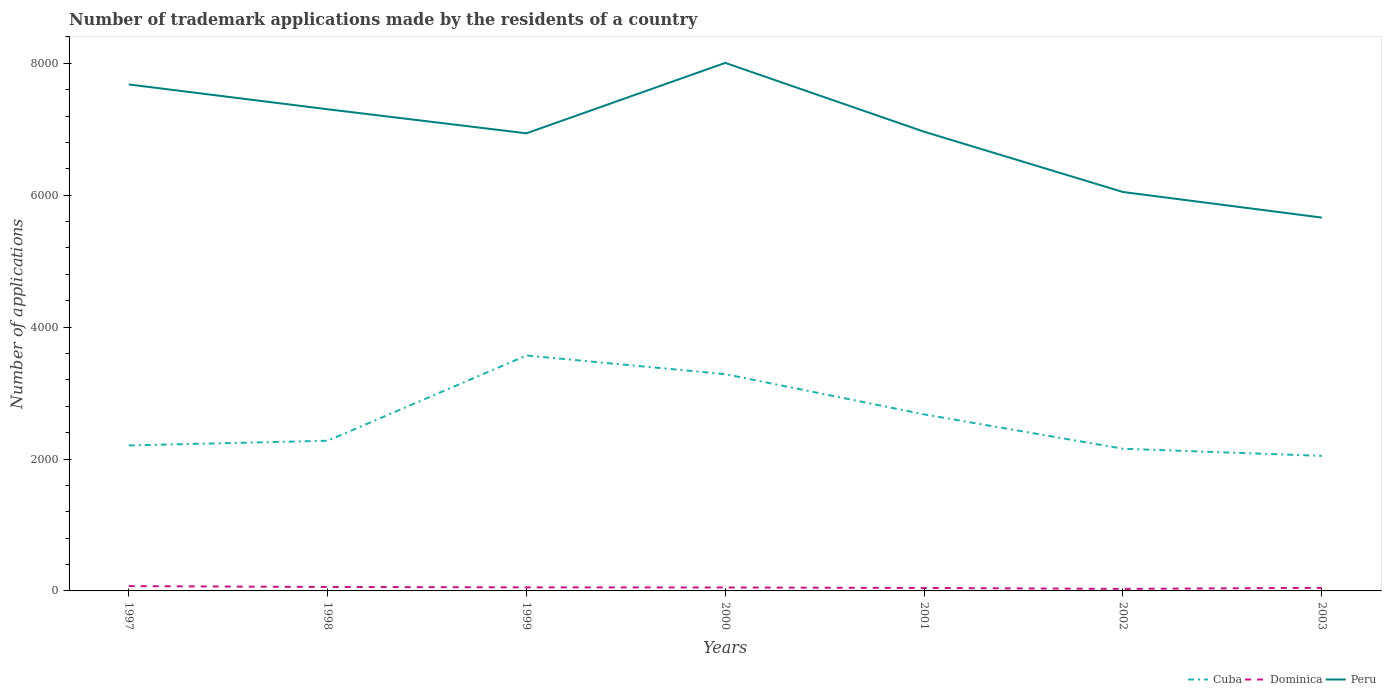How many different coloured lines are there?
Provide a short and direct response. 3. Does the line corresponding to Dominica intersect with the line corresponding to Cuba?
Your answer should be compact. No. Across all years, what is the maximum number of trademark applications made by the residents in Peru?
Offer a terse response. 5661. In which year was the number of trademark applications made by the residents in Dominica maximum?
Your answer should be very brief. 2002. What is the total number of trademark applications made by the residents in Peru in the graph?
Your response must be concise. 741. What is the difference between the highest and the second highest number of trademark applications made by the residents in Cuba?
Offer a terse response. 1522. How many lines are there?
Provide a succinct answer. 3. What is the difference between two consecutive major ticks on the Y-axis?
Offer a terse response. 2000. Does the graph contain grids?
Your response must be concise. No. Where does the legend appear in the graph?
Provide a short and direct response. Bottom right. What is the title of the graph?
Ensure brevity in your answer.  Number of trademark applications made by the residents of a country. What is the label or title of the X-axis?
Make the answer very short. Years. What is the label or title of the Y-axis?
Offer a terse response. Number of applications. What is the Number of applications in Cuba in 1997?
Provide a succinct answer. 2206. What is the Number of applications of Dominica in 1997?
Provide a succinct answer. 73. What is the Number of applications in Peru in 1997?
Offer a very short reply. 7680. What is the Number of applications of Cuba in 1998?
Give a very brief answer. 2277. What is the Number of applications of Peru in 1998?
Your answer should be compact. 7304. What is the Number of applications of Cuba in 1999?
Your response must be concise. 3570. What is the Number of applications in Peru in 1999?
Ensure brevity in your answer.  6939. What is the Number of applications of Cuba in 2000?
Offer a terse response. 3287. What is the Number of applications in Peru in 2000?
Keep it short and to the point. 8007. What is the Number of applications in Cuba in 2001?
Give a very brief answer. 2677. What is the Number of applications in Dominica in 2001?
Offer a terse response. 45. What is the Number of applications in Peru in 2001?
Offer a very short reply. 6963. What is the Number of applications in Cuba in 2002?
Provide a short and direct response. 2156. What is the Number of applications in Peru in 2002?
Ensure brevity in your answer.  6049. What is the Number of applications of Cuba in 2003?
Provide a short and direct response. 2048. What is the Number of applications in Dominica in 2003?
Keep it short and to the point. 47. What is the Number of applications of Peru in 2003?
Your answer should be compact. 5661. Across all years, what is the maximum Number of applications in Cuba?
Offer a very short reply. 3570. Across all years, what is the maximum Number of applications in Dominica?
Ensure brevity in your answer.  73. Across all years, what is the maximum Number of applications in Peru?
Offer a terse response. 8007. Across all years, what is the minimum Number of applications in Cuba?
Ensure brevity in your answer.  2048. Across all years, what is the minimum Number of applications of Dominica?
Keep it short and to the point. 31. Across all years, what is the minimum Number of applications in Peru?
Offer a terse response. 5661. What is the total Number of applications of Cuba in the graph?
Your answer should be compact. 1.82e+04. What is the total Number of applications in Dominica in the graph?
Your answer should be compact. 362. What is the total Number of applications of Peru in the graph?
Your answer should be very brief. 4.86e+04. What is the difference between the Number of applications in Cuba in 1997 and that in 1998?
Make the answer very short. -71. What is the difference between the Number of applications of Peru in 1997 and that in 1998?
Give a very brief answer. 376. What is the difference between the Number of applications of Cuba in 1997 and that in 1999?
Your answer should be very brief. -1364. What is the difference between the Number of applications of Peru in 1997 and that in 1999?
Offer a terse response. 741. What is the difference between the Number of applications in Cuba in 1997 and that in 2000?
Your answer should be very brief. -1081. What is the difference between the Number of applications of Peru in 1997 and that in 2000?
Your response must be concise. -327. What is the difference between the Number of applications of Cuba in 1997 and that in 2001?
Make the answer very short. -471. What is the difference between the Number of applications in Peru in 1997 and that in 2001?
Your answer should be compact. 717. What is the difference between the Number of applications in Cuba in 1997 and that in 2002?
Offer a terse response. 50. What is the difference between the Number of applications of Peru in 1997 and that in 2002?
Keep it short and to the point. 1631. What is the difference between the Number of applications of Cuba in 1997 and that in 2003?
Give a very brief answer. 158. What is the difference between the Number of applications of Dominica in 1997 and that in 2003?
Provide a short and direct response. 26. What is the difference between the Number of applications of Peru in 1997 and that in 2003?
Ensure brevity in your answer.  2019. What is the difference between the Number of applications of Cuba in 1998 and that in 1999?
Make the answer very short. -1293. What is the difference between the Number of applications in Dominica in 1998 and that in 1999?
Offer a terse response. 6. What is the difference between the Number of applications of Peru in 1998 and that in 1999?
Your answer should be very brief. 365. What is the difference between the Number of applications of Cuba in 1998 and that in 2000?
Offer a very short reply. -1010. What is the difference between the Number of applications in Peru in 1998 and that in 2000?
Offer a terse response. -703. What is the difference between the Number of applications of Cuba in 1998 and that in 2001?
Provide a succinct answer. -400. What is the difference between the Number of applications in Dominica in 1998 and that in 2001?
Ensure brevity in your answer.  15. What is the difference between the Number of applications in Peru in 1998 and that in 2001?
Your response must be concise. 341. What is the difference between the Number of applications of Cuba in 1998 and that in 2002?
Offer a terse response. 121. What is the difference between the Number of applications in Dominica in 1998 and that in 2002?
Ensure brevity in your answer.  29. What is the difference between the Number of applications of Peru in 1998 and that in 2002?
Your response must be concise. 1255. What is the difference between the Number of applications of Cuba in 1998 and that in 2003?
Provide a short and direct response. 229. What is the difference between the Number of applications of Dominica in 1998 and that in 2003?
Provide a succinct answer. 13. What is the difference between the Number of applications in Peru in 1998 and that in 2003?
Make the answer very short. 1643. What is the difference between the Number of applications of Cuba in 1999 and that in 2000?
Your answer should be compact. 283. What is the difference between the Number of applications of Dominica in 1999 and that in 2000?
Provide a succinct answer. 2. What is the difference between the Number of applications of Peru in 1999 and that in 2000?
Offer a very short reply. -1068. What is the difference between the Number of applications of Cuba in 1999 and that in 2001?
Make the answer very short. 893. What is the difference between the Number of applications of Dominica in 1999 and that in 2001?
Your answer should be very brief. 9. What is the difference between the Number of applications of Cuba in 1999 and that in 2002?
Your response must be concise. 1414. What is the difference between the Number of applications in Dominica in 1999 and that in 2002?
Make the answer very short. 23. What is the difference between the Number of applications of Peru in 1999 and that in 2002?
Your response must be concise. 890. What is the difference between the Number of applications in Cuba in 1999 and that in 2003?
Your answer should be compact. 1522. What is the difference between the Number of applications in Peru in 1999 and that in 2003?
Ensure brevity in your answer.  1278. What is the difference between the Number of applications of Cuba in 2000 and that in 2001?
Ensure brevity in your answer.  610. What is the difference between the Number of applications of Dominica in 2000 and that in 2001?
Offer a very short reply. 7. What is the difference between the Number of applications of Peru in 2000 and that in 2001?
Offer a very short reply. 1044. What is the difference between the Number of applications in Cuba in 2000 and that in 2002?
Provide a short and direct response. 1131. What is the difference between the Number of applications in Peru in 2000 and that in 2002?
Give a very brief answer. 1958. What is the difference between the Number of applications in Cuba in 2000 and that in 2003?
Your answer should be very brief. 1239. What is the difference between the Number of applications of Peru in 2000 and that in 2003?
Provide a succinct answer. 2346. What is the difference between the Number of applications in Cuba in 2001 and that in 2002?
Offer a terse response. 521. What is the difference between the Number of applications in Dominica in 2001 and that in 2002?
Provide a succinct answer. 14. What is the difference between the Number of applications of Peru in 2001 and that in 2002?
Keep it short and to the point. 914. What is the difference between the Number of applications in Cuba in 2001 and that in 2003?
Provide a short and direct response. 629. What is the difference between the Number of applications in Dominica in 2001 and that in 2003?
Your answer should be very brief. -2. What is the difference between the Number of applications of Peru in 2001 and that in 2003?
Keep it short and to the point. 1302. What is the difference between the Number of applications of Cuba in 2002 and that in 2003?
Your response must be concise. 108. What is the difference between the Number of applications of Dominica in 2002 and that in 2003?
Your answer should be compact. -16. What is the difference between the Number of applications in Peru in 2002 and that in 2003?
Keep it short and to the point. 388. What is the difference between the Number of applications in Cuba in 1997 and the Number of applications in Dominica in 1998?
Offer a very short reply. 2146. What is the difference between the Number of applications of Cuba in 1997 and the Number of applications of Peru in 1998?
Make the answer very short. -5098. What is the difference between the Number of applications of Dominica in 1997 and the Number of applications of Peru in 1998?
Give a very brief answer. -7231. What is the difference between the Number of applications of Cuba in 1997 and the Number of applications of Dominica in 1999?
Your answer should be very brief. 2152. What is the difference between the Number of applications in Cuba in 1997 and the Number of applications in Peru in 1999?
Provide a short and direct response. -4733. What is the difference between the Number of applications of Dominica in 1997 and the Number of applications of Peru in 1999?
Your response must be concise. -6866. What is the difference between the Number of applications in Cuba in 1997 and the Number of applications in Dominica in 2000?
Keep it short and to the point. 2154. What is the difference between the Number of applications in Cuba in 1997 and the Number of applications in Peru in 2000?
Provide a short and direct response. -5801. What is the difference between the Number of applications in Dominica in 1997 and the Number of applications in Peru in 2000?
Give a very brief answer. -7934. What is the difference between the Number of applications in Cuba in 1997 and the Number of applications in Dominica in 2001?
Keep it short and to the point. 2161. What is the difference between the Number of applications in Cuba in 1997 and the Number of applications in Peru in 2001?
Give a very brief answer. -4757. What is the difference between the Number of applications in Dominica in 1997 and the Number of applications in Peru in 2001?
Offer a terse response. -6890. What is the difference between the Number of applications of Cuba in 1997 and the Number of applications of Dominica in 2002?
Provide a short and direct response. 2175. What is the difference between the Number of applications of Cuba in 1997 and the Number of applications of Peru in 2002?
Provide a succinct answer. -3843. What is the difference between the Number of applications of Dominica in 1997 and the Number of applications of Peru in 2002?
Ensure brevity in your answer.  -5976. What is the difference between the Number of applications in Cuba in 1997 and the Number of applications in Dominica in 2003?
Offer a terse response. 2159. What is the difference between the Number of applications in Cuba in 1997 and the Number of applications in Peru in 2003?
Offer a terse response. -3455. What is the difference between the Number of applications in Dominica in 1997 and the Number of applications in Peru in 2003?
Offer a terse response. -5588. What is the difference between the Number of applications of Cuba in 1998 and the Number of applications of Dominica in 1999?
Offer a very short reply. 2223. What is the difference between the Number of applications of Cuba in 1998 and the Number of applications of Peru in 1999?
Offer a very short reply. -4662. What is the difference between the Number of applications in Dominica in 1998 and the Number of applications in Peru in 1999?
Offer a terse response. -6879. What is the difference between the Number of applications of Cuba in 1998 and the Number of applications of Dominica in 2000?
Offer a terse response. 2225. What is the difference between the Number of applications of Cuba in 1998 and the Number of applications of Peru in 2000?
Offer a terse response. -5730. What is the difference between the Number of applications of Dominica in 1998 and the Number of applications of Peru in 2000?
Offer a terse response. -7947. What is the difference between the Number of applications of Cuba in 1998 and the Number of applications of Dominica in 2001?
Your answer should be very brief. 2232. What is the difference between the Number of applications in Cuba in 1998 and the Number of applications in Peru in 2001?
Keep it short and to the point. -4686. What is the difference between the Number of applications in Dominica in 1998 and the Number of applications in Peru in 2001?
Your answer should be very brief. -6903. What is the difference between the Number of applications of Cuba in 1998 and the Number of applications of Dominica in 2002?
Give a very brief answer. 2246. What is the difference between the Number of applications in Cuba in 1998 and the Number of applications in Peru in 2002?
Offer a very short reply. -3772. What is the difference between the Number of applications of Dominica in 1998 and the Number of applications of Peru in 2002?
Offer a terse response. -5989. What is the difference between the Number of applications in Cuba in 1998 and the Number of applications in Dominica in 2003?
Give a very brief answer. 2230. What is the difference between the Number of applications of Cuba in 1998 and the Number of applications of Peru in 2003?
Offer a terse response. -3384. What is the difference between the Number of applications in Dominica in 1998 and the Number of applications in Peru in 2003?
Your answer should be very brief. -5601. What is the difference between the Number of applications in Cuba in 1999 and the Number of applications in Dominica in 2000?
Make the answer very short. 3518. What is the difference between the Number of applications in Cuba in 1999 and the Number of applications in Peru in 2000?
Your answer should be compact. -4437. What is the difference between the Number of applications of Dominica in 1999 and the Number of applications of Peru in 2000?
Offer a terse response. -7953. What is the difference between the Number of applications in Cuba in 1999 and the Number of applications in Dominica in 2001?
Your answer should be compact. 3525. What is the difference between the Number of applications in Cuba in 1999 and the Number of applications in Peru in 2001?
Offer a terse response. -3393. What is the difference between the Number of applications of Dominica in 1999 and the Number of applications of Peru in 2001?
Offer a very short reply. -6909. What is the difference between the Number of applications in Cuba in 1999 and the Number of applications in Dominica in 2002?
Your response must be concise. 3539. What is the difference between the Number of applications of Cuba in 1999 and the Number of applications of Peru in 2002?
Make the answer very short. -2479. What is the difference between the Number of applications in Dominica in 1999 and the Number of applications in Peru in 2002?
Offer a terse response. -5995. What is the difference between the Number of applications of Cuba in 1999 and the Number of applications of Dominica in 2003?
Your answer should be compact. 3523. What is the difference between the Number of applications of Cuba in 1999 and the Number of applications of Peru in 2003?
Your answer should be very brief. -2091. What is the difference between the Number of applications of Dominica in 1999 and the Number of applications of Peru in 2003?
Provide a short and direct response. -5607. What is the difference between the Number of applications of Cuba in 2000 and the Number of applications of Dominica in 2001?
Provide a short and direct response. 3242. What is the difference between the Number of applications of Cuba in 2000 and the Number of applications of Peru in 2001?
Your response must be concise. -3676. What is the difference between the Number of applications of Dominica in 2000 and the Number of applications of Peru in 2001?
Your answer should be compact. -6911. What is the difference between the Number of applications in Cuba in 2000 and the Number of applications in Dominica in 2002?
Offer a terse response. 3256. What is the difference between the Number of applications of Cuba in 2000 and the Number of applications of Peru in 2002?
Your response must be concise. -2762. What is the difference between the Number of applications of Dominica in 2000 and the Number of applications of Peru in 2002?
Your answer should be compact. -5997. What is the difference between the Number of applications of Cuba in 2000 and the Number of applications of Dominica in 2003?
Offer a terse response. 3240. What is the difference between the Number of applications in Cuba in 2000 and the Number of applications in Peru in 2003?
Your response must be concise. -2374. What is the difference between the Number of applications of Dominica in 2000 and the Number of applications of Peru in 2003?
Keep it short and to the point. -5609. What is the difference between the Number of applications of Cuba in 2001 and the Number of applications of Dominica in 2002?
Offer a very short reply. 2646. What is the difference between the Number of applications of Cuba in 2001 and the Number of applications of Peru in 2002?
Provide a succinct answer. -3372. What is the difference between the Number of applications in Dominica in 2001 and the Number of applications in Peru in 2002?
Your answer should be very brief. -6004. What is the difference between the Number of applications of Cuba in 2001 and the Number of applications of Dominica in 2003?
Provide a short and direct response. 2630. What is the difference between the Number of applications of Cuba in 2001 and the Number of applications of Peru in 2003?
Provide a short and direct response. -2984. What is the difference between the Number of applications in Dominica in 2001 and the Number of applications in Peru in 2003?
Offer a very short reply. -5616. What is the difference between the Number of applications in Cuba in 2002 and the Number of applications in Dominica in 2003?
Your answer should be compact. 2109. What is the difference between the Number of applications of Cuba in 2002 and the Number of applications of Peru in 2003?
Offer a very short reply. -3505. What is the difference between the Number of applications of Dominica in 2002 and the Number of applications of Peru in 2003?
Provide a short and direct response. -5630. What is the average Number of applications in Cuba per year?
Ensure brevity in your answer.  2603. What is the average Number of applications of Dominica per year?
Provide a succinct answer. 51.71. What is the average Number of applications in Peru per year?
Offer a terse response. 6943.29. In the year 1997, what is the difference between the Number of applications in Cuba and Number of applications in Dominica?
Ensure brevity in your answer.  2133. In the year 1997, what is the difference between the Number of applications of Cuba and Number of applications of Peru?
Provide a succinct answer. -5474. In the year 1997, what is the difference between the Number of applications of Dominica and Number of applications of Peru?
Make the answer very short. -7607. In the year 1998, what is the difference between the Number of applications in Cuba and Number of applications in Dominica?
Your answer should be very brief. 2217. In the year 1998, what is the difference between the Number of applications of Cuba and Number of applications of Peru?
Your answer should be compact. -5027. In the year 1998, what is the difference between the Number of applications of Dominica and Number of applications of Peru?
Give a very brief answer. -7244. In the year 1999, what is the difference between the Number of applications in Cuba and Number of applications in Dominica?
Provide a short and direct response. 3516. In the year 1999, what is the difference between the Number of applications of Cuba and Number of applications of Peru?
Provide a succinct answer. -3369. In the year 1999, what is the difference between the Number of applications in Dominica and Number of applications in Peru?
Your answer should be very brief. -6885. In the year 2000, what is the difference between the Number of applications of Cuba and Number of applications of Dominica?
Give a very brief answer. 3235. In the year 2000, what is the difference between the Number of applications in Cuba and Number of applications in Peru?
Your response must be concise. -4720. In the year 2000, what is the difference between the Number of applications of Dominica and Number of applications of Peru?
Provide a succinct answer. -7955. In the year 2001, what is the difference between the Number of applications of Cuba and Number of applications of Dominica?
Keep it short and to the point. 2632. In the year 2001, what is the difference between the Number of applications in Cuba and Number of applications in Peru?
Provide a succinct answer. -4286. In the year 2001, what is the difference between the Number of applications in Dominica and Number of applications in Peru?
Provide a short and direct response. -6918. In the year 2002, what is the difference between the Number of applications of Cuba and Number of applications of Dominica?
Keep it short and to the point. 2125. In the year 2002, what is the difference between the Number of applications of Cuba and Number of applications of Peru?
Provide a succinct answer. -3893. In the year 2002, what is the difference between the Number of applications in Dominica and Number of applications in Peru?
Your answer should be very brief. -6018. In the year 2003, what is the difference between the Number of applications in Cuba and Number of applications in Dominica?
Make the answer very short. 2001. In the year 2003, what is the difference between the Number of applications of Cuba and Number of applications of Peru?
Ensure brevity in your answer.  -3613. In the year 2003, what is the difference between the Number of applications in Dominica and Number of applications in Peru?
Ensure brevity in your answer.  -5614. What is the ratio of the Number of applications in Cuba in 1997 to that in 1998?
Ensure brevity in your answer.  0.97. What is the ratio of the Number of applications in Dominica in 1997 to that in 1998?
Provide a succinct answer. 1.22. What is the ratio of the Number of applications of Peru in 1997 to that in 1998?
Offer a terse response. 1.05. What is the ratio of the Number of applications of Cuba in 1997 to that in 1999?
Keep it short and to the point. 0.62. What is the ratio of the Number of applications of Dominica in 1997 to that in 1999?
Your response must be concise. 1.35. What is the ratio of the Number of applications in Peru in 1997 to that in 1999?
Your response must be concise. 1.11. What is the ratio of the Number of applications of Cuba in 1997 to that in 2000?
Make the answer very short. 0.67. What is the ratio of the Number of applications of Dominica in 1997 to that in 2000?
Offer a terse response. 1.4. What is the ratio of the Number of applications in Peru in 1997 to that in 2000?
Provide a succinct answer. 0.96. What is the ratio of the Number of applications in Cuba in 1997 to that in 2001?
Make the answer very short. 0.82. What is the ratio of the Number of applications in Dominica in 1997 to that in 2001?
Your response must be concise. 1.62. What is the ratio of the Number of applications in Peru in 1997 to that in 2001?
Your answer should be very brief. 1.1. What is the ratio of the Number of applications in Cuba in 1997 to that in 2002?
Your response must be concise. 1.02. What is the ratio of the Number of applications of Dominica in 1997 to that in 2002?
Offer a terse response. 2.35. What is the ratio of the Number of applications in Peru in 1997 to that in 2002?
Your answer should be compact. 1.27. What is the ratio of the Number of applications in Cuba in 1997 to that in 2003?
Your answer should be compact. 1.08. What is the ratio of the Number of applications in Dominica in 1997 to that in 2003?
Give a very brief answer. 1.55. What is the ratio of the Number of applications in Peru in 1997 to that in 2003?
Provide a succinct answer. 1.36. What is the ratio of the Number of applications of Cuba in 1998 to that in 1999?
Your answer should be very brief. 0.64. What is the ratio of the Number of applications in Dominica in 1998 to that in 1999?
Make the answer very short. 1.11. What is the ratio of the Number of applications in Peru in 1998 to that in 1999?
Ensure brevity in your answer.  1.05. What is the ratio of the Number of applications in Cuba in 1998 to that in 2000?
Provide a succinct answer. 0.69. What is the ratio of the Number of applications in Dominica in 1998 to that in 2000?
Provide a short and direct response. 1.15. What is the ratio of the Number of applications in Peru in 1998 to that in 2000?
Provide a succinct answer. 0.91. What is the ratio of the Number of applications of Cuba in 1998 to that in 2001?
Offer a very short reply. 0.85. What is the ratio of the Number of applications in Peru in 1998 to that in 2001?
Make the answer very short. 1.05. What is the ratio of the Number of applications in Cuba in 1998 to that in 2002?
Provide a short and direct response. 1.06. What is the ratio of the Number of applications of Dominica in 1998 to that in 2002?
Offer a terse response. 1.94. What is the ratio of the Number of applications of Peru in 1998 to that in 2002?
Provide a succinct answer. 1.21. What is the ratio of the Number of applications in Cuba in 1998 to that in 2003?
Give a very brief answer. 1.11. What is the ratio of the Number of applications in Dominica in 1998 to that in 2003?
Offer a very short reply. 1.28. What is the ratio of the Number of applications in Peru in 1998 to that in 2003?
Provide a succinct answer. 1.29. What is the ratio of the Number of applications of Cuba in 1999 to that in 2000?
Make the answer very short. 1.09. What is the ratio of the Number of applications in Dominica in 1999 to that in 2000?
Your response must be concise. 1.04. What is the ratio of the Number of applications of Peru in 1999 to that in 2000?
Your answer should be compact. 0.87. What is the ratio of the Number of applications in Cuba in 1999 to that in 2001?
Offer a very short reply. 1.33. What is the ratio of the Number of applications of Peru in 1999 to that in 2001?
Provide a short and direct response. 1. What is the ratio of the Number of applications in Cuba in 1999 to that in 2002?
Ensure brevity in your answer.  1.66. What is the ratio of the Number of applications of Dominica in 1999 to that in 2002?
Your answer should be very brief. 1.74. What is the ratio of the Number of applications in Peru in 1999 to that in 2002?
Give a very brief answer. 1.15. What is the ratio of the Number of applications in Cuba in 1999 to that in 2003?
Your answer should be compact. 1.74. What is the ratio of the Number of applications of Dominica in 1999 to that in 2003?
Keep it short and to the point. 1.15. What is the ratio of the Number of applications of Peru in 1999 to that in 2003?
Your answer should be compact. 1.23. What is the ratio of the Number of applications in Cuba in 2000 to that in 2001?
Provide a succinct answer. 1.23. What is the ratio of the Number of applications of Dominica in 2000 to that in 2001?
Offer a very short reply. 1.16. What is the ratio of the Number of applications in Peru in 2000 to that in 2001?
Provide a succinct answer. 1.15. What is the ratio of the Number of applications of Cuba in 2000 to that in 2002?
Keep it short and to the point. 1.52. What is the ratio of the Number of applications of Dominica in 2000 to that in 2002?
Offer a very short reply. 1.68. What is the ratio of the Number of applications of Peru in 2000 to that in 2002?
Offer a terse response. 1.32. What is the ratio of the Number of applications of Cuba in 2000 to that in 2003?
Give a very brief answer. 1.6. What is the ratio of the Number of applications in Dominica in 2000 to that in 2003?
Provide a short and direct response. 1.11. What is the ratio of the Number of applications in Peru in 2000 to that in 2003?
Provide a succinct answer. 1.41. What is the ratio of the Number of applications of Cuba in 2001 to that in 2002?
Provide a short and direct response. 1.24. What is the ratio of the Number of applications in Dominica in 2001 to that in 2002?
Keep it short and to the point. 1.45. What is the ratio of the Number of applications in Peru in 2001 to that in 2002?
Keep it short and to the point. 1.15. What is the ratio of the Number of applications of Cuba in 2001 to that in 2003?
Your answer should be very brief. 1.31. What is the ratio of the Number of applications of Dominica in 2001 to that in 2003?
Ensure brevity in your answer.  0.96. What is the ratio of the Number of applications in Peru in 2001 to that in 2003?
Provide a succinct answer. 1.23. What is the ratio of the Number of applications in Cuba in 2002 to that in 2003?
Provide a short and direct response. 1.05. What is the ratio of the Number of applications in Dominica in 2002 to that in 2003?
Offer a very short reply. 0.66. What is the ratio of the Number of applications of Peru in 2002 to that in 2003?
Your response must be concise. 1.07. What is the difference between the highest and the second highest Number of applications in Cuba?
Keep it short and to the point. 283. What is the difference between the highest and the second highest Number of applications of Peru?
Your response must be concise. 327. What is the difference between the highest and the lowest Number of applications in Cuba?
Your answer should be very brief. 1522. What is the difference between the highest and the lowest Number of applications of Peru?
Give a very brief answer. 2346. 